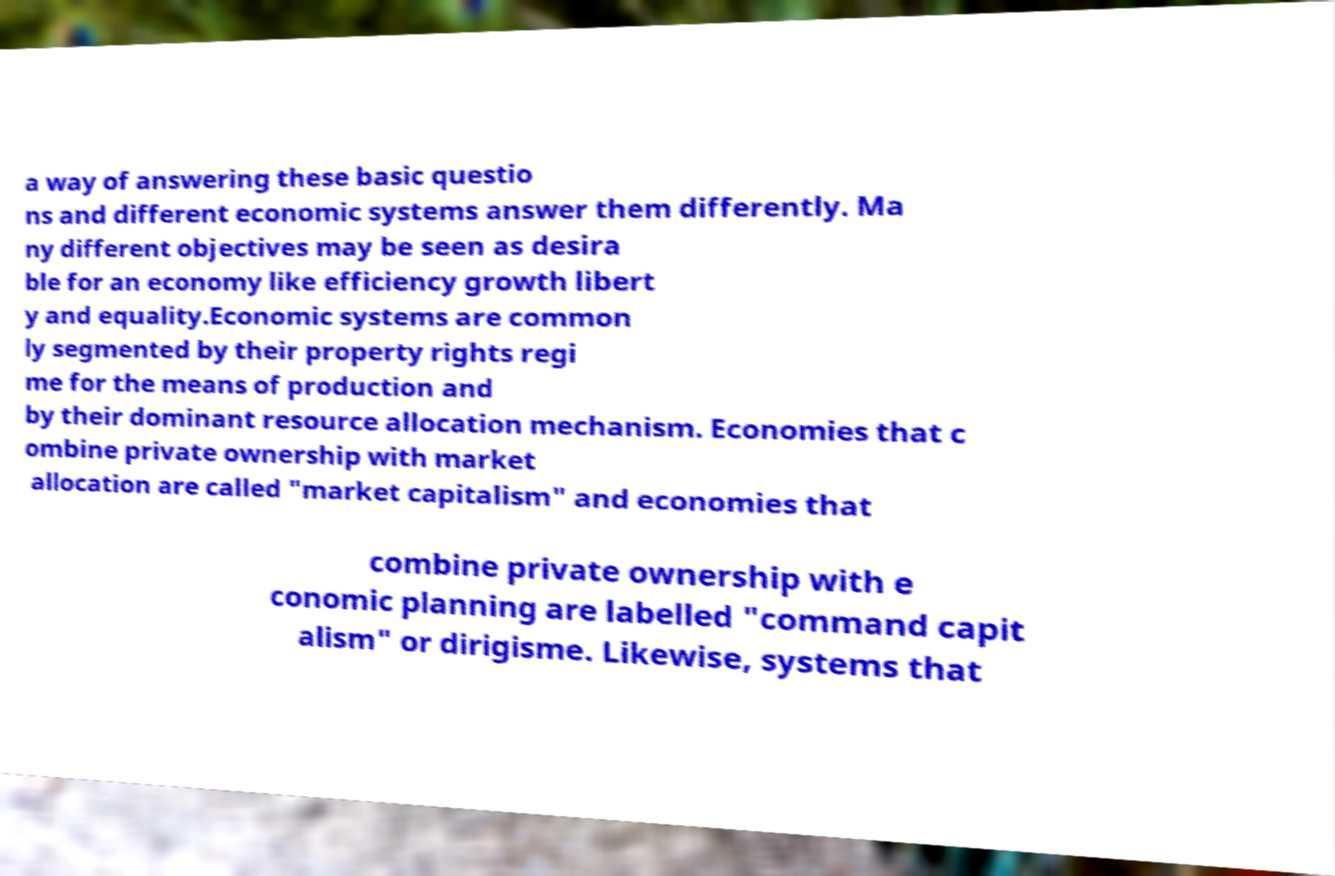What messages or text are displayed in this image? I need them in a readable, typed format. a way of answering these basic questio ns and different economic systems answer them differently. Ma ny different objectives may be seen as desira ble for an economy like efficiency growth libert y and equality.Economic systems are common ly segmented by their property rights regi me for the means of production and by their dominant resource allocation mechanism. Economies that c ombine private ownership with market allocation are called "market capitalism" and economies that combine private ownership with e conomic planning are labelled "command capit alism" or dirigisme. Likewise, systems that 